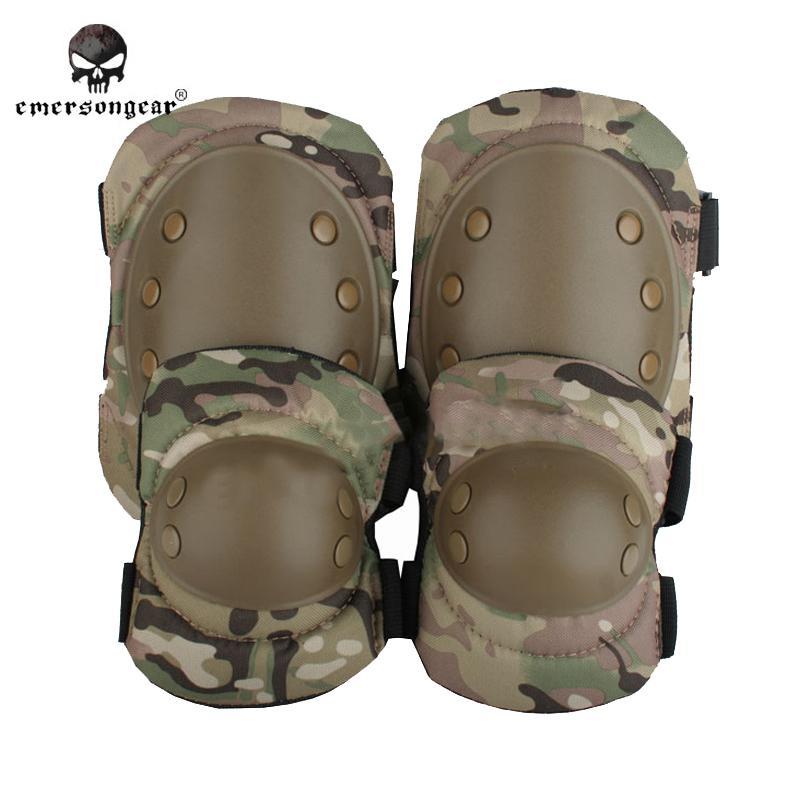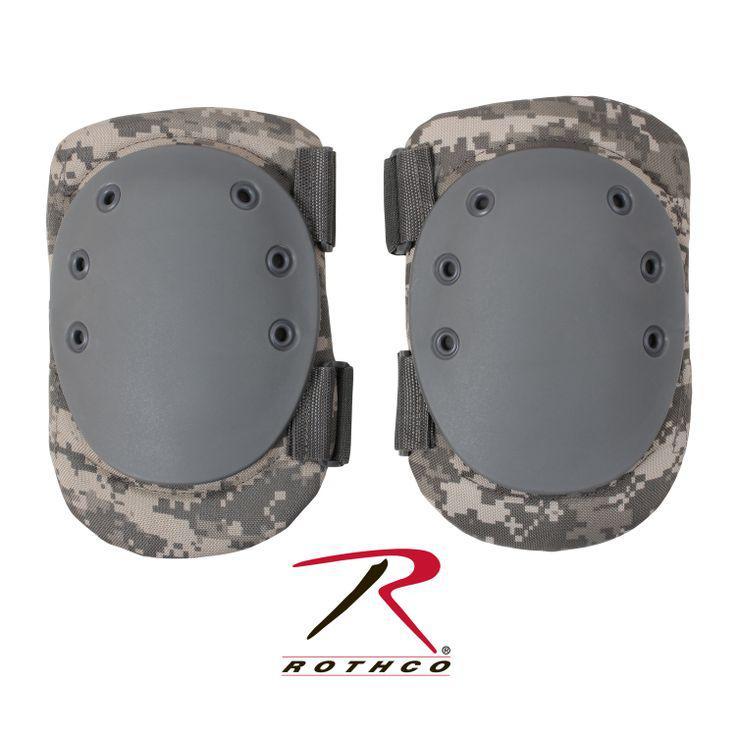The first image is the image on the left, the second image is the image on the right. Evaluate the accuracy of this statement regarding the images: "The kneepads in one image are camouflage and the other image has tan kneepads.". Is it true? Answer yes or no. No. The first image is the image on the left, the second image is the image on the right. Given the left and right images, does the statement "There are four knee pads facing forward in total." hold true? Answer yes or no. Yes. 